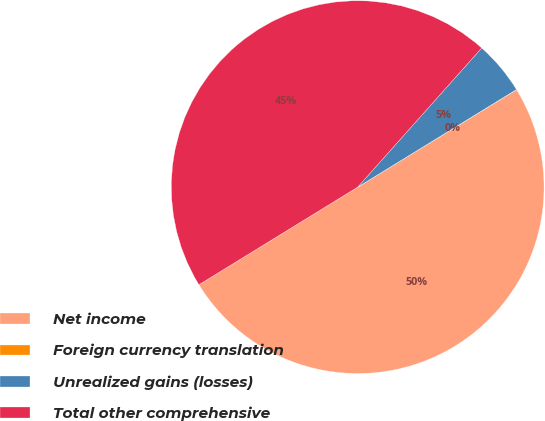Convert chart to OTSL. <chart><loc_0><loc_0><loc_500><loc_500><pie_chart><fcel>Net income<fcel>Foreign currency translation<fcel>Unrealized gains (losses)<fcel>Total other comprehensive<nl><fcel>49.98%<fcel>0.02%<fcel>4.64%<fcel>45.36%<nl></chart> 